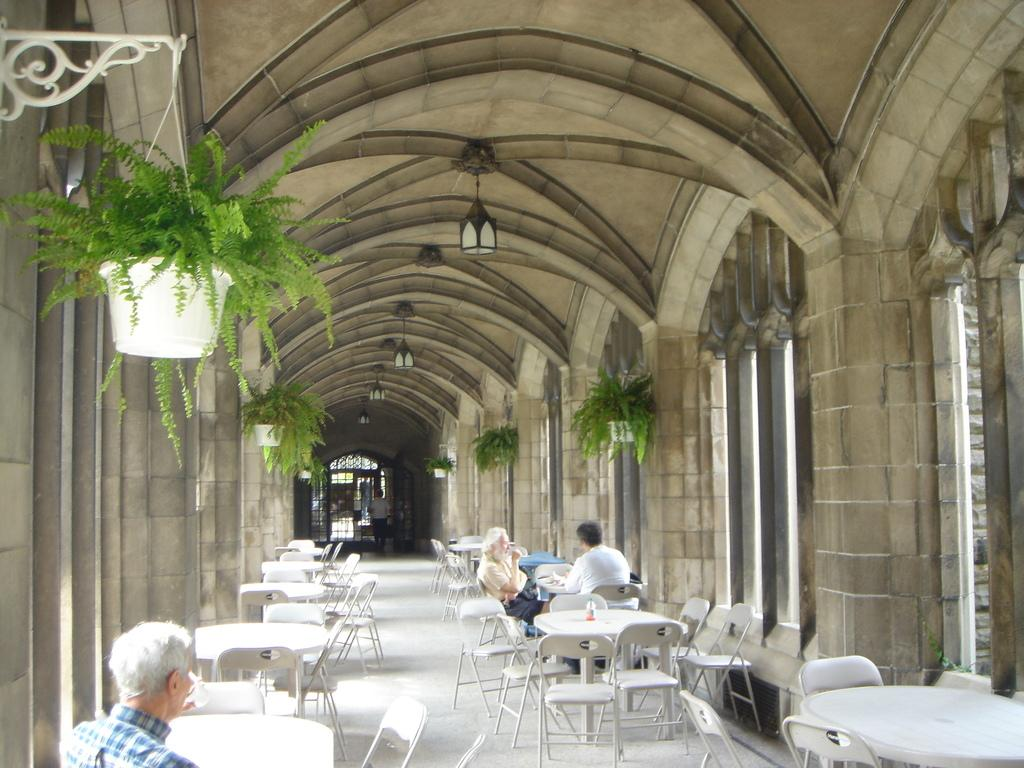How many people are sitting in the image? There are three people sitting on chairs in the image. What type of furniture is present in the image? There are chairs and tables in the image. What can be seen in the image that is related to plants? There are plants with pots in the image. What is the purpose of the rod in the image? The purpose of the rod in the image is not clear from the provided facts. Can you describe the background of the image? In the background of the image, there is a person and a door. What is there is any steam coming out of the plants in the image? There is not present in the image. What is the view from the window in the background of the image? There is no window visible in the image, so it is not possible to describe the view. 